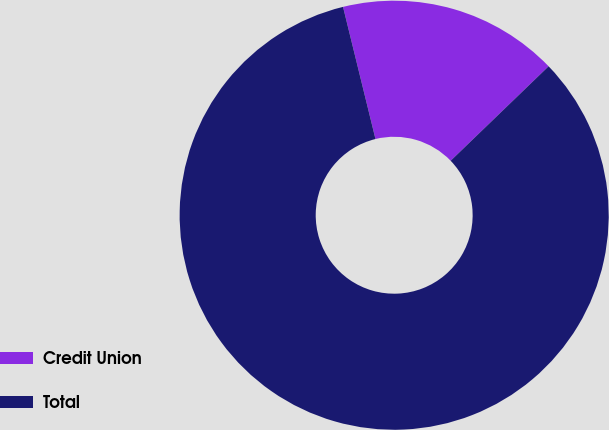<chart> <loc_0><loc_0><loc_500><loc_500><pie_chart><fcel>Credit Union<fcel>Total<nl><fcel>16.62%<fcel>83.38%<nl></chart> 